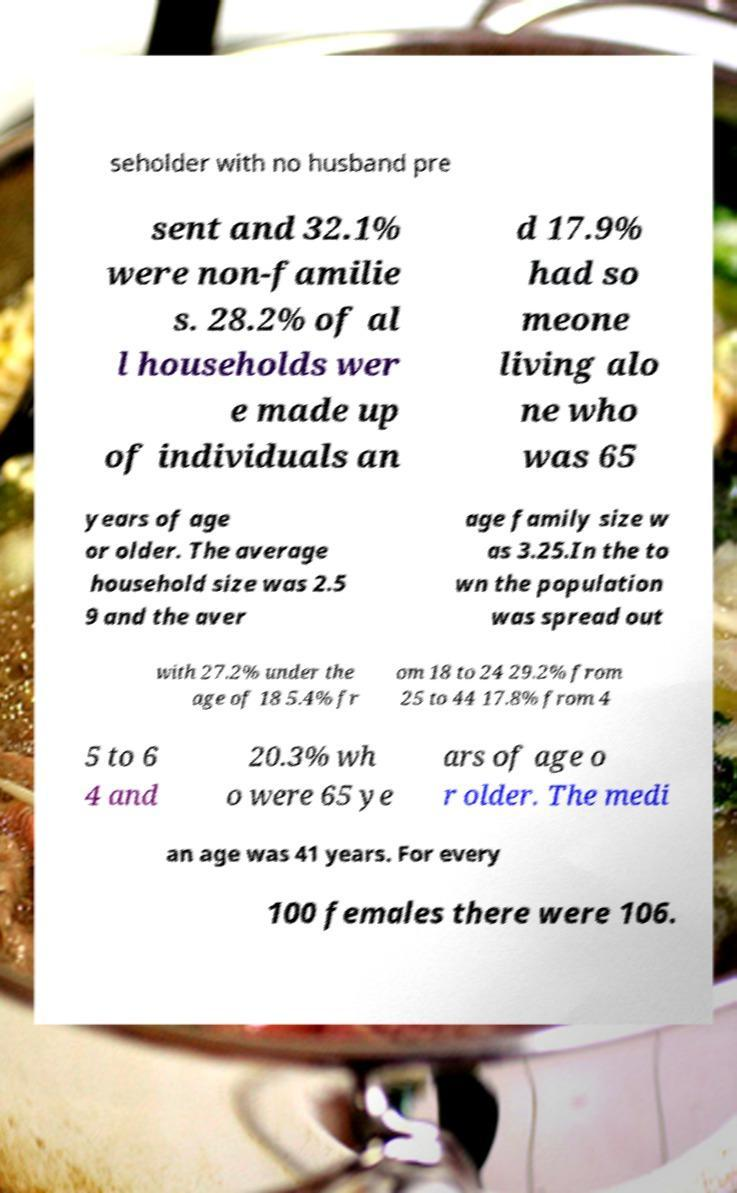Could you assist in decoding the text presented in this image and type it out clearly? seholder with no husband pre sent and 32.1% were non-familie s. 28.2% of al l households wer e made up of individuals an d 17.9% had so meone living alo ne who was 65 years of age or older. The average household size was 2.5 9 and the aver age family size w as 3.25.In the to wn the population was spread out with 27.2% under the age of 18 5.4% fr om 18 to 24 29.2% from 25 to 44 17.8% from 4 5 to 6 4 and 20.3% wh o were 65 ye ars of age o r older. The medi an age was 41 years. For every 100 females there were 106. 